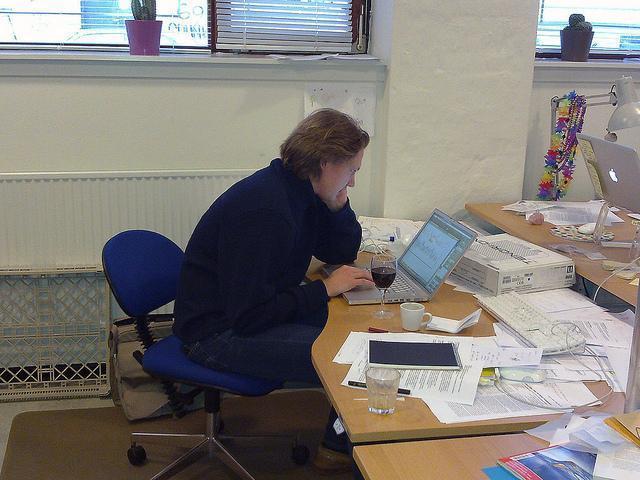How many laptops can you see?
Give a very brief answer. 2. 